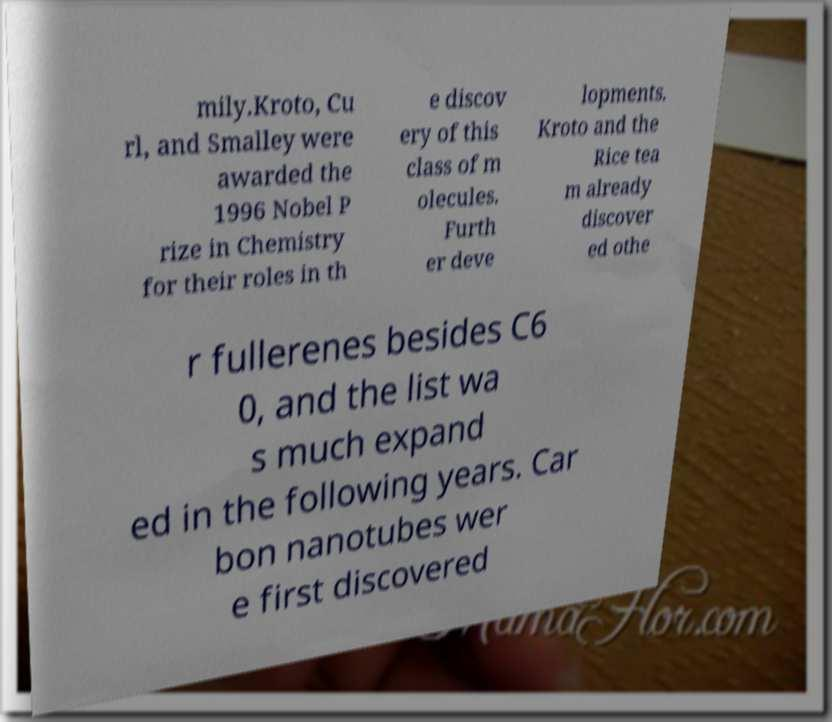What messages or text are displayed in this image? I need them in a readable, typed format. mily.Kroto, Cu rl, and Smalley were awarded the 1996 Nobel P rize in Chemistry for their roles in th e discov ery of this class of m olecules. Furth er deve lopments. Kroto and the Rice tea m already discover ed othe r fullerenes besides C6 0, and the list wa s much expand ed in the following years. Car bon nanotubes wer e first discovered 